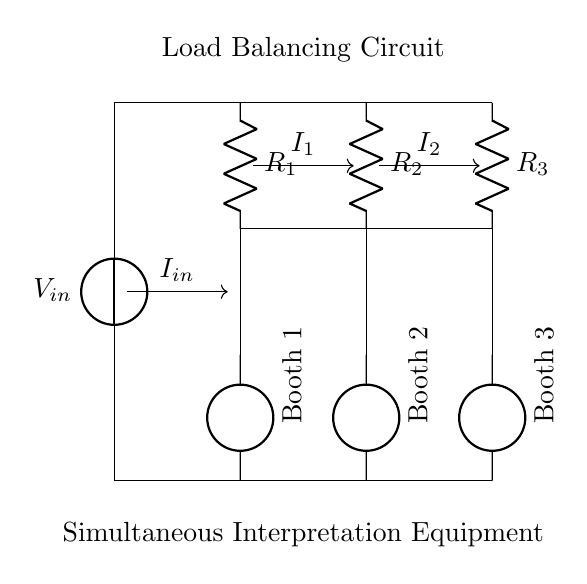What is the input voltage in this circuit? The input voltage is labeled as V_in at the top of the circuit diagram. It is the voltage source supplying power to the circuit.
Answer: V_in Which component exhibits the lowest resistance? The circuit contains three resistors labeled as R_1, R_2, and R_3. To identify the one with the lowest resistance, one would need their specific resistance values; however, based on the labels only, no specific value is given.
Answer: None specified How many booths are connected to this load balancing circuit? The diagram clearly shows three interpretation booths connected, labeled as Booth 1, Booth 2, and Booth 3 positioned at the bottom of the diagram.
Answer: Three What is the relationship between the input current and the currents through the booths? The total input current I_in is divided among the booths as currents I_1, I_2, and I_3. The current divider principle states that the current entering a parallel circuit is equal to the sum of the currents through each branch.
Answer: I_in = I_1 + I_2 + I_3 What type of circuit configuration is used in this diagram? The configuration used is a current divider, where multiple branches (booths) share the total current supplied by a single source, according to their resistances.
Answer: Current Divider 